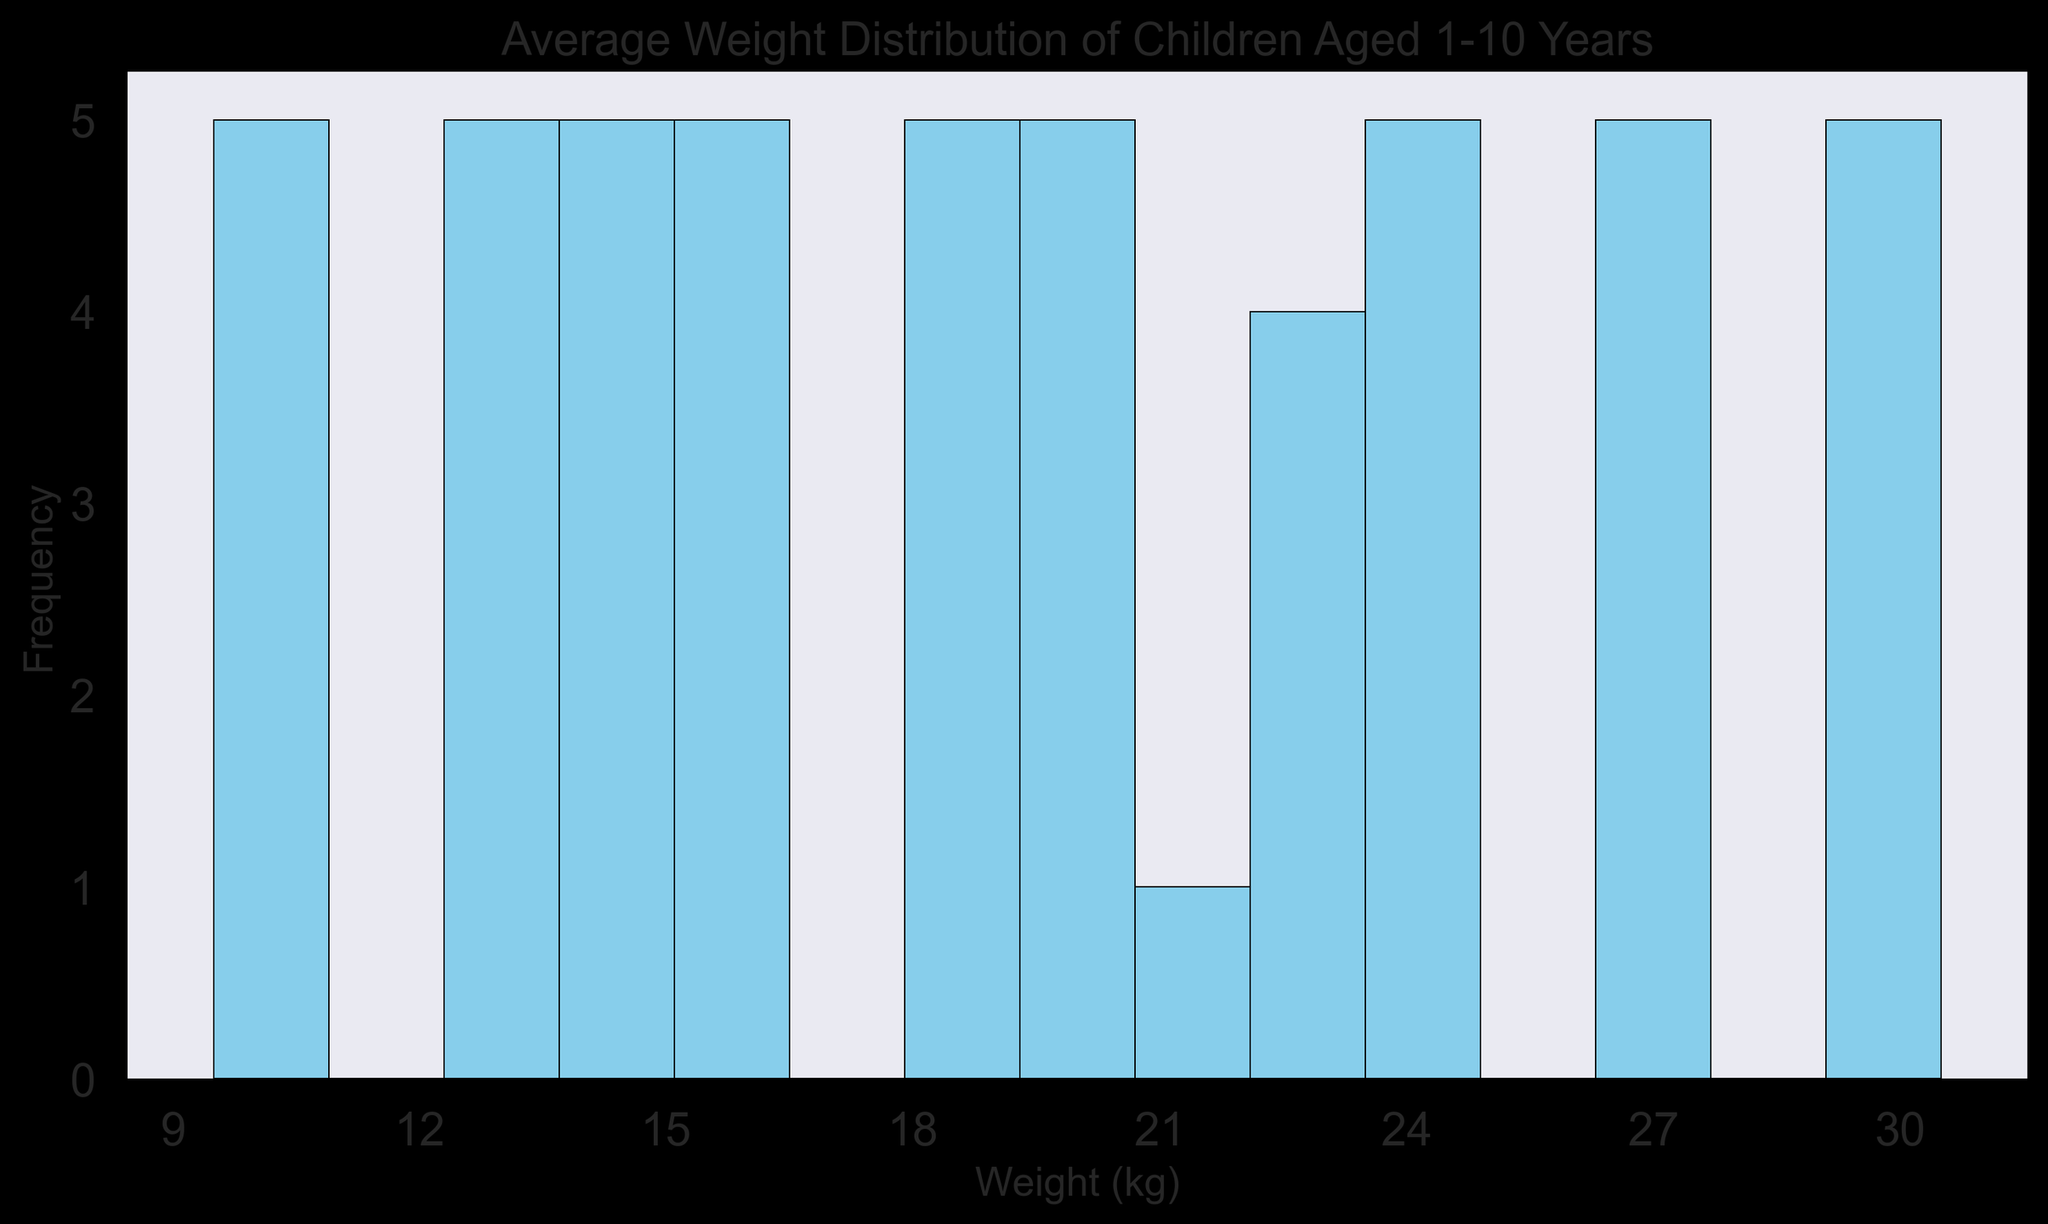Which age group has the highest average weight? To determine the highest average weight, observe the age groups sequentially on the histogram. The histogram bars representing the age group 10 will likely be located at the higher end of the x-axis with clustering of weights around 30 kg, indicating that children aged 10 years have the highest average weight.
Answer: Age group 10 Which age group has the highest frequency of weights around 24-25 kg? Look at the histogram's bars around the weight range from 24 to 25 kg. The tallest bar in this range corresponds to age group 8, indicating the highest frequency of weights in this range.
Answer: Age group 8 What is the most common weight range for children aged 1 year? Find the bins that correspond to children aged 1 year on the histogram, focusing on the lower end of the weight spectrum. The bars around 9.5 to 10.5 kg will be the tallest for this group, showing the most common weight range.
Answer: 9.5-10.5 kg Which age group shows the least variation in weight? Examine the width of the clusters for each age group. The narrower the cluster, the lesser the variation. The weights for age group 6 tightly cluster around the 20-21 kg mark, indicating minimal variation.
Answer: Age group 6 Is there any age group whose weight distribution overlaps significantly with another age group’s distribution? Scanning the histogram, weights of age groups 4 and 5 around 16-19 kg show significant overlap, indicating that these age groups have a considerable weight distribution overlap.
Answer: Age group 4 and 5 How many children weigh more than 25 kg? Identify all the segments of the histogram where weight is more than 25 kg and count the total number of children. The relevant bars are near 27 kg and above, specifically from age groups 9 and 10. Summing the frequency of these bars gives the total number.
Answer: 10 children Which age group corresponds to a weight range clustered around 14-15 kg? Check for the histogram bars that cluster around 14-15 kg on the x-axis. Observing the bars, these weights are most frequent around age group 3.
Answer: Age group 3 What is the frequency of children weighing exactly 30 kg? Find the bar on the histogram specifically at 30 kg on the x-axis and note its height. In the histogram, age group 10 has a bar indicating that there is only one child weighing exactly 30 kg.
Answer: 1 child What is the average weight for children in the age group 5-6 years? To determine the average weight, find the bars for age groups 5 and 6: Age group 5 weights cluster around 18 kg and age group 6 weights around 20 kg. Averaging these dominant weights gives (18 + 20) / 2 = 19 kg.
Answer: 19 kg 